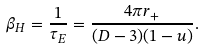<formula> <loc_0><loc_0><loc_500><loc_500>\beta _ { H } = \frac { 1 } { \tau _ { E } } = \frac { 4 \pi r _ { + } } { ( D - 3 ) ( 1 - u ) } .</formula> 